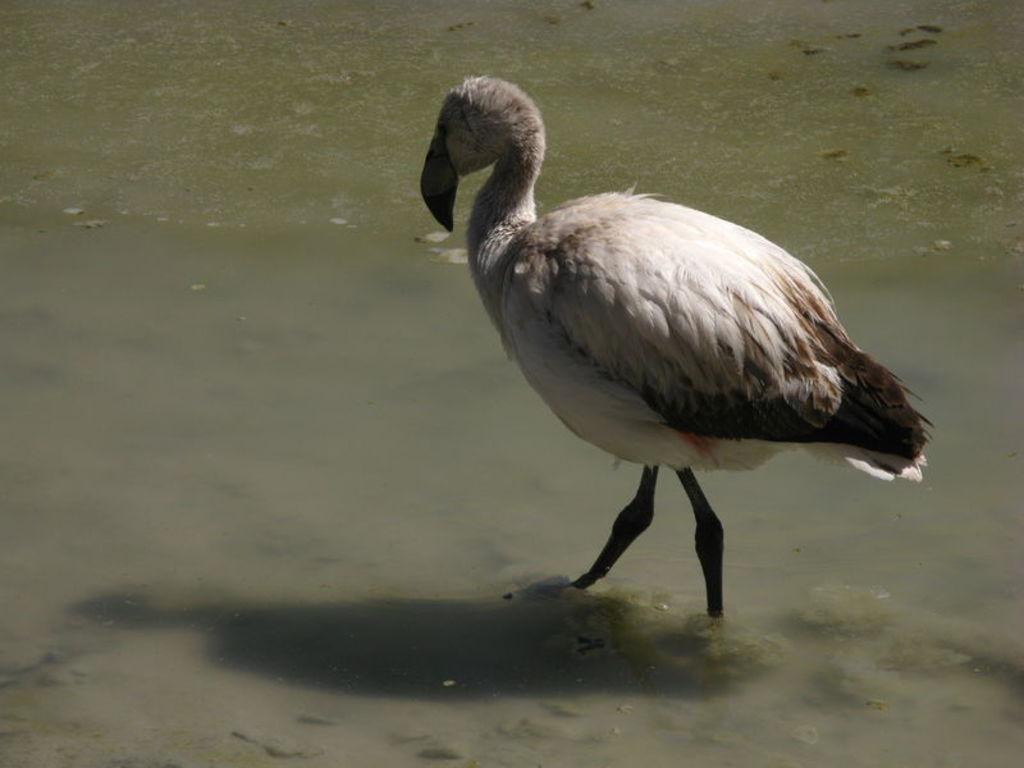Could you give a brief overview of what you see in this image? In the image there is a duck walking in the water. 